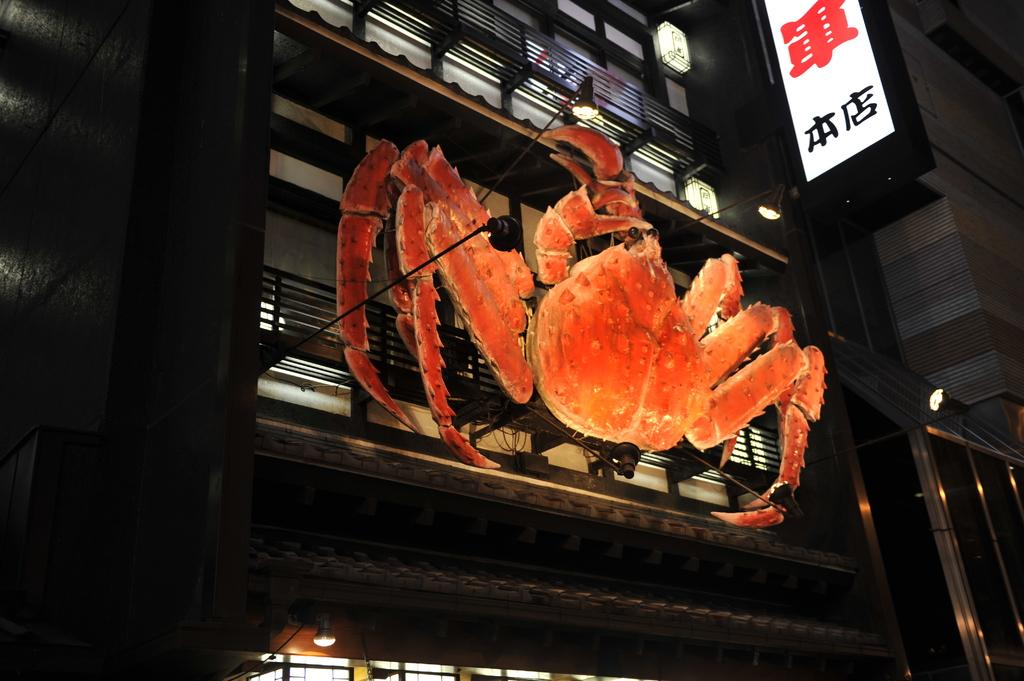What is the orange object in the image shaped like? The orange object in the image is shaped like a crab. What can be seen on the board in the image? The provided facts do not mention anything specific about the board, so we cannot answer this question definitively. What type of illumination is present in the image? There are lights in the image. What kind of structure is present in the image? There is a railing in the image. What type of corn is being used to decorate the railing in the image? There is no corn present in the image, so we cannot answer this question. 